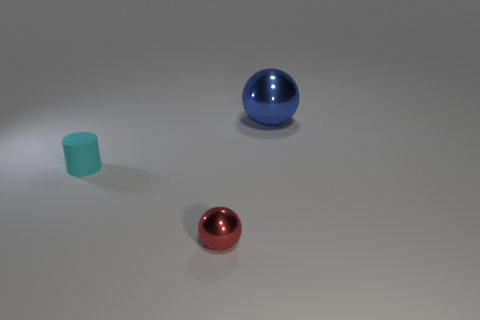Are there fewer small purple cylinders than red metal things?
Your response must be concise. Yes. How many other metal objects have the same shape as the red object?
Ensure brevity in your answer.  1. What color is the shiny object that is the same size as the cyan matte thing?
Your answer should be very brief. Red. Is the number of tiny cyan rubber cylinders that are behind the big blue metal ball the same as the number of cyan rubber cylinders that are on the right side of the small cylinder?
Your answer should be very brief. Yes. Is there another red thing of the same size as the matte object?
Make the answer very short. Yes. What size is the red ball?
Your response must be concise. Small. Are there an equal number of rubber cylinders that are right of the large blue ball and big cyan cylinders?
Give a very brief answer. Yes. How many other objects are there of the same color as the large metallic thing?
Offer a terse response. 0. There is a thing that is both to the right of the cyan cylinder and in front of the large sphere; what is its color?
Your response must be concise. Red. There is a metal ball to the right of the shiny object in front of the ball that is behind the small cyan cylinder; how big is it?
Ensure brevity in your answer.  Large. 